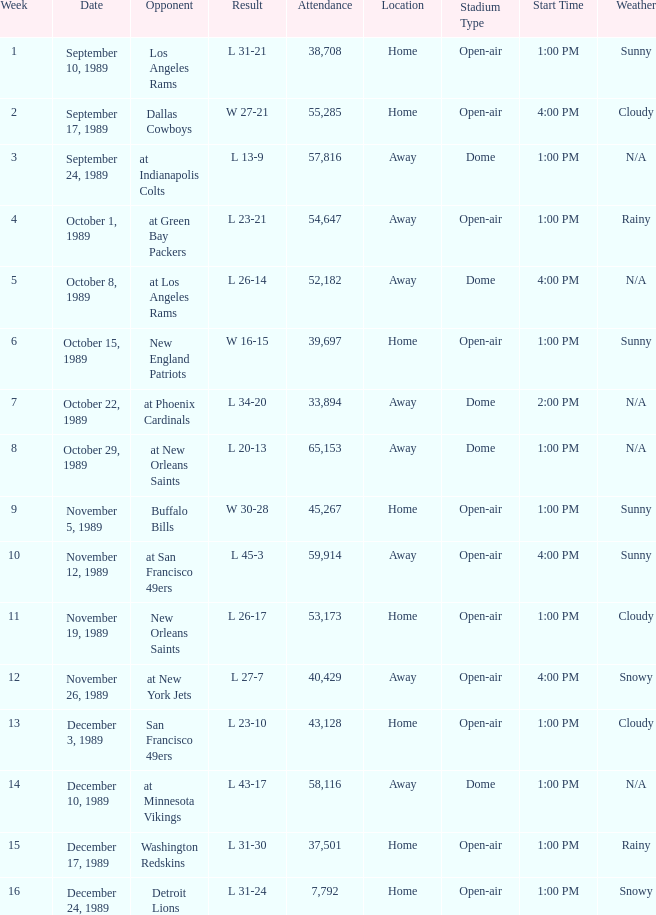What week featured a game with the detroit lions? 16.0. 